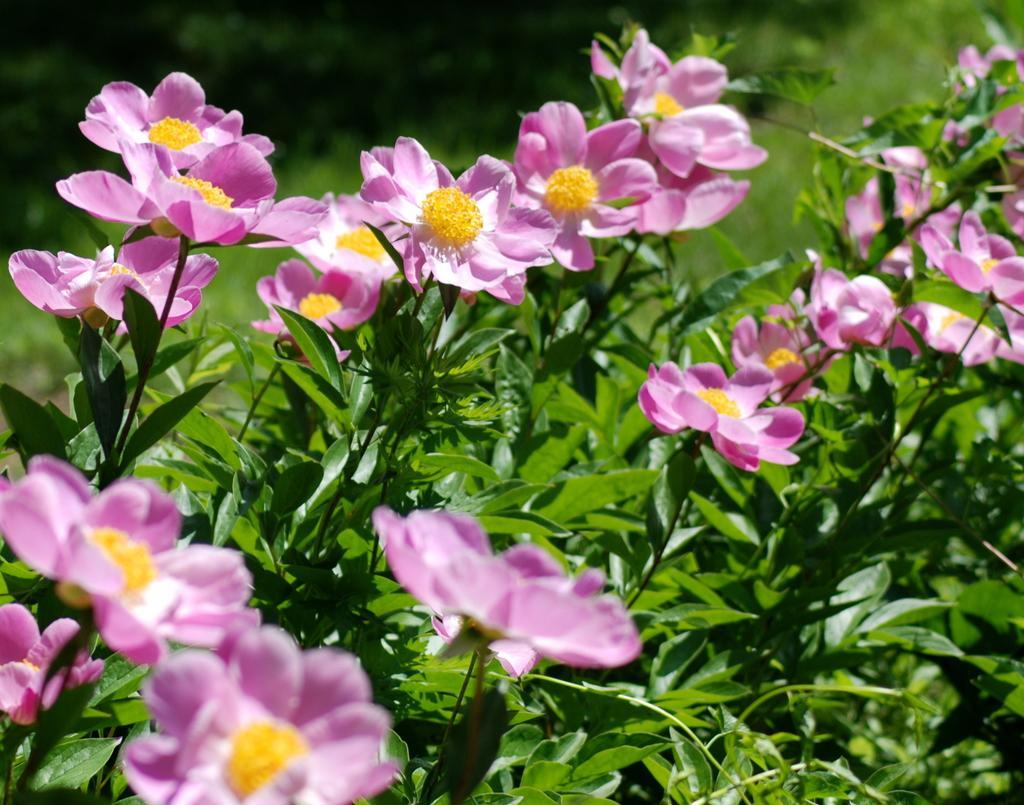In one or two sentences, can you explain what this image depicts? In this picture I can see flower plants. The flowers are pink in color. 